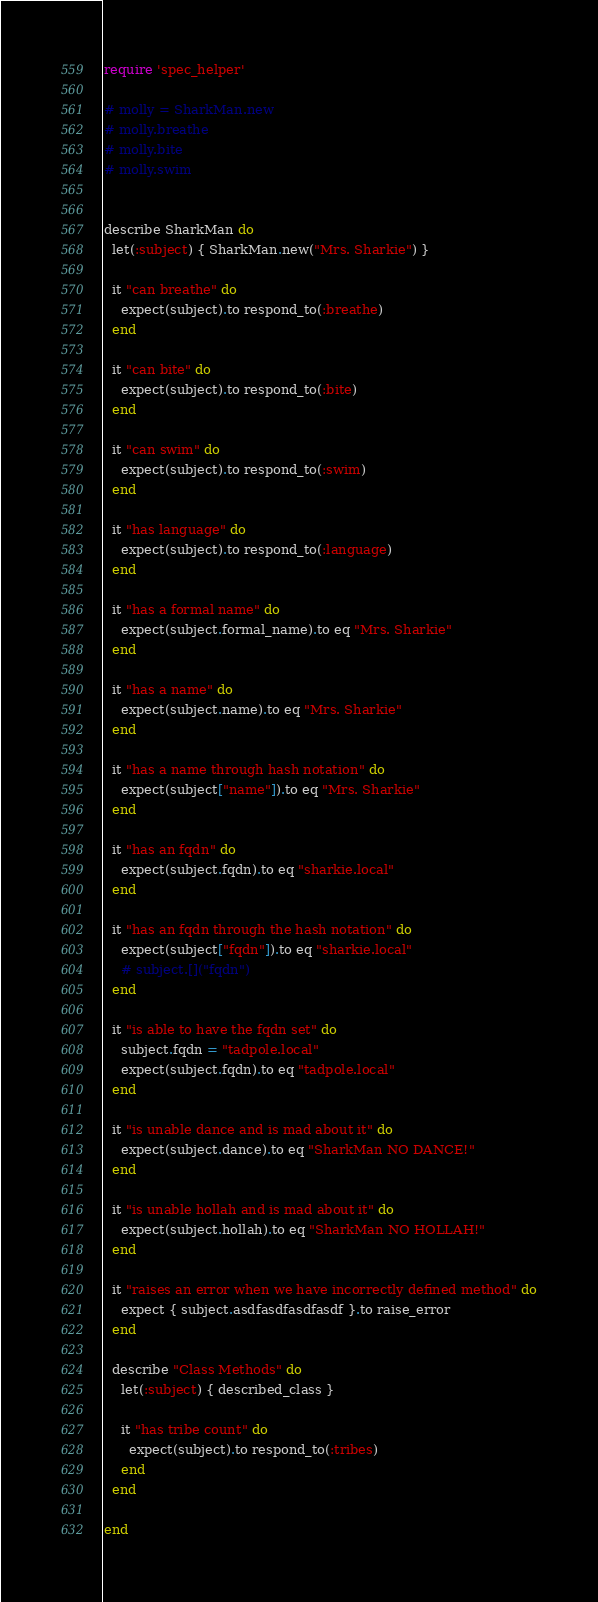<code> <loc_0><loc_0><loc_500><loc_500><_Ruby_>require 'spec_helper'

# molly = SharkMan.new
# molly.breathe
# molly.bite
# molly.swim


describe SharkMan do
  let(:subject) { SharkMan.new("Mrs. Sharkie") }

  it "can breathe" do
    expect(subject).to respond_to(:breathe)
  end

  it "can bite" do
    expect(subject).to respond_to(:bite)
  end

  it "can swim" do
    expect(subject).to respond_to(:swim)
  end

  it "has language" do
    expect(subject).to respond_to(:language)
  end

  it "has a formal name" do
    expect(subject.formal_name).to eq "Mrs. Sharkie"
  end

  it "has a name" do
    expect(subject.name).to eq "Mrs. Sharkie"
  end

  it "has a name through hash notation" do
    expect(subject["name"]).to eq "Mrs. Sharkie"
  end

  it "has an fqdn" do
    expect(subject.fqdn).to eq "sharkie.local"
  end

  it "has an fqdn through the hash notation" do
    expect(subject["fqdn"]).to eq "sharkie.local"
    # subject.[]("fqdn")
  end

  it "is able to have the fqdn set" do
    subject.fqdn = "tadpole.local"
    expect(subject.fqdn).to eq "tadpole.local"
  end

  it "is unable dance and is mad about it" do
    expect(subject.dance).to eq "SharkMan NO DANCE!"
  end

  it "is unable hollah and is mad about it" do
    expect(subject.hollah).to eq "SharkMan NO HOLLAH!"
  end

  it "raises an error when we have incorrectly defined method" do
    expect { subject.asdfasdfasdfasdf }.to raise_error
  end

  describe "Class Methods" do
    let(:subject) { described_class }

    it "has tribe count" do
      expect(subject).to respond_to(:tribes)
    end
  end

end</code> 